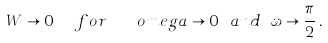<formula> <loc_0><loc_0><loc_500><loc_500>W \rightarrow 0 \ \ f o r \ \ \ o m e g a \rightarrow 0 \ a n d \ \omega \rightarrow \frac { \pi } { 2 } \, .</formula> 